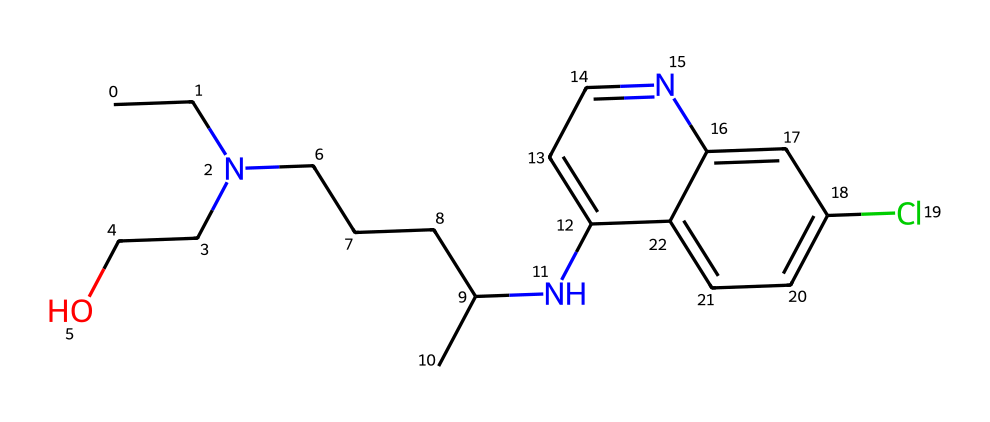What is the molecular formula of hydroxychloroquine? The SMILES representation can be converted to the molecular formula by counting the number of each type of atom. This structure includes the following elements: carbon (C), hydrogen (H), nitrogen (N), chlorine (Cl), and oxygen (O). By analyzing the structure, we determine that the molecular formula of hydroxychloroquine is C18H26ClN3O.
Answer: C18H26ClN3O How many carbon atoms are present in this compound? The SMILES notation reveals the carbon chain and ring structures. By counting the 'C' characters in the SMILES, we find a total of 18 carbon atoms.
Answer: 18 What functional groups are present in hydroxychloroquine? Analyzing the structure, we identify key functional groups, including an amine group (-NH), a hydroxy group (-OH), and a chloro substituent (-Cl). The presence of these groups indicates the compound's properties and reactivity.
Answer: amine, hydroxy, chloro Which part of the molecule contributes to its antiviral properties? The presence of the amine and hydroxy groups in the structure enhances the interaction of the compound with biological targets, which is critical for its action as an antiviral. The nitrogen atoms in the amine group facilitate bonding interactions, making this part significant for its medicinal activity.
Answer: amine and hydroxy groups What type of chemical is hydroxychloroquine classified as? Hydroxychloroquine is classified as an antimalarial drug, which is a type of medicinal compound. The presence of nitrogen in its structure indicates it is a pharmaceutical compound used for therapeutic purposes.
Answer: antimalarial drug 